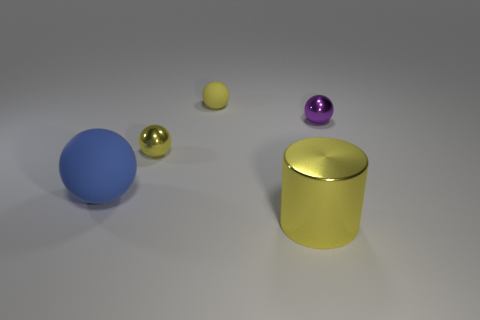Subtract all blue rubber balls. How many balls are left? 3 Subtract all cyan cubes. How many yellow spheres are left? 2 Subtract all blue spheres. How many spheres are left? 3 Add 4 cyan matte cubes. How many objects exist? 9 Subtract all spheres. How many objects are left? 1 Subtract all blue spheres. Subtract all blue cubes. How many spheres are left? 3 Add 1 small metallic spheres. How many small metallic spheres are left? 3 Add 2 big blue balls. How many big blue balls exist? 3 Subtract 0 red spheres. How many objects are left? 5 Subtract all cyan rubber objects. Subtract all tiny metallic balls. How many objects are left? 3 